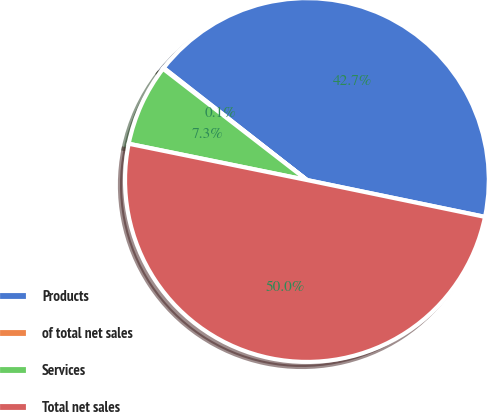Convert chart to OTSL. <chart><loc_0><loc_0><loc_500><loc_500><pie_chart><fcel>Products<fcel>of total net sales<fcel>Services<fcel>Total net sales<nl><fcel>42.68%<fcel>0.09%<fcel>7.28%<fcel>49.95%<nl></chart> 